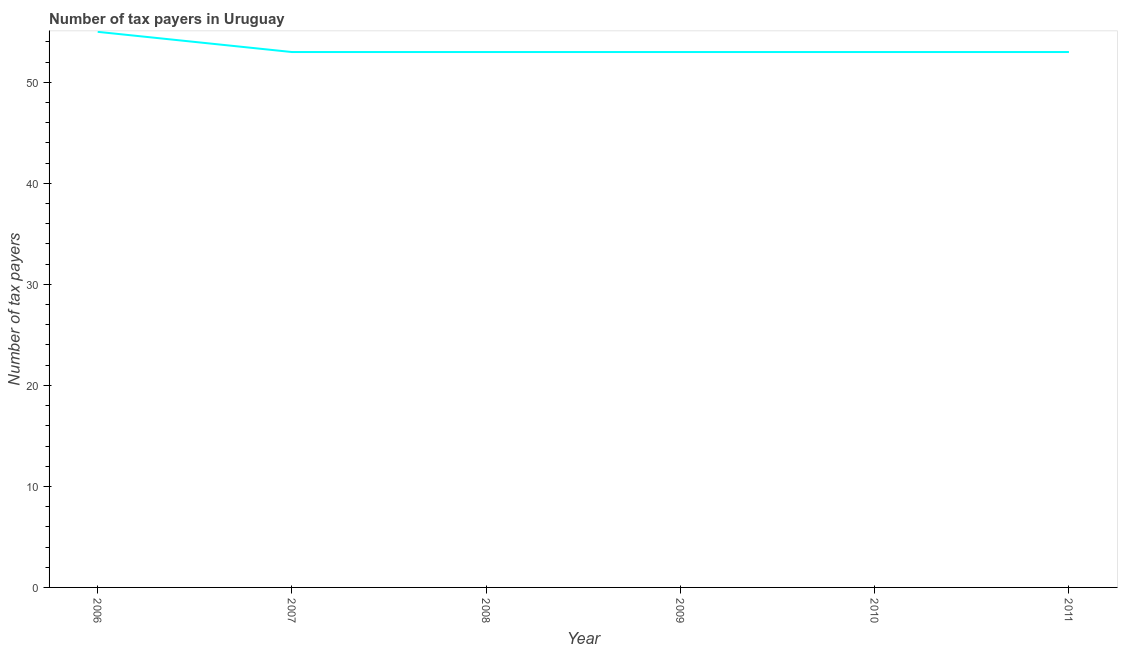What is the number of tax payers in 2009?
Ensure brevity in your answer.  53. Across all years, what is the maximum number of tax payers?
Your answer should be very brief. 55. Across all years, what is the minimum number of tax payers?
Provide a short and direct response. 53. In which year was the number of tax payers maximum?
Give a very brief answer. 2006. In which year was the number of tax payers minimum?
Your answer should be compact. 2007. What is the sum of the number of tax payers?
Your response must be concise. 320. What is the difference between the number of tax payers in 2007 and 2008?
Your response must be concise. 0. What is the average number of tax payers per year?
Offer a terse response. 53.33. What is the median number of tax payers?
Your answer should be very brief. 53. In how many years, is the number of tax payers greater than 10 ?
Provide a short and direct response. 6. What is the ratio of the number of tax payers in 2007 to that in 2009?
Provide a succinct answer. 1. Is the sum of the number of tax payers in 2008 and 2010 greater than the maximum number of tax payers across all years?
Your response must be concise. Yes. What is the difference between the highest and the lowest number of tax payers?
Give a very brief answer. 2. How many years are there in the graph?
Offer a terse response. 6. What is the difference between two consecutive major ticks on the Y-axis?
Keep it short and to the point. 10. Does the graph contain any zero values?
Your answer should be very brief. No. Does the graph contain grids?
Offer a terse response. No. What is the title of the graph?
Ensure brevity in your answer.  Number of tax payers in Uruguay. What is the label or title of the X-axis?
Your answer should be very brief. Year. What is the label or title of the Y-axis?
Keep it short and to the point. Number of tax payers. What is the Number of tax payers in 2007?
Your answer should be compact. 53. What is the Number of tax payers of 2011?
Provide a short and direct response. 53. What is the difference between the Number of tax payers in 2006 and 2007?
Provide a succinct answer. 2. What is the difference between the Number of tax payers in 2006 and 2011?
Give a very brief answer. 2. What is the difference between the Number of tax payers in 2007 and 2011?
Provide a short and direct response. 0. What is the difference between the Number of tax payers in 2008 and 2010?
Keep it short and to the point. 0. What is the difference between the Number of tax payers in 2008 and 2011?
Offer a very short reply. 0. What is the difference between the Number of tax payers in 2009 and 2010?
Provide a succinct answer. 0. What is the difference between the Number of tax payers in 2009 and 2011?
Provide a succinct answer. 0. What is the ratio of the Number of tax payers in 2006 to that in 2007?
Your response must be concise. 1.04. What is the ratio of the Number of tax payers in 2006 to that in 2008?
Your answer should be compact. 1.04. What is the ratio of the Number of tax payers in 2006 to that in 2009?
Provide a short and direct response. 1.04. What is the ratio of the Number of tax payers in 2006 to that in 2010?
Offer a terse response. 1.04. What is the ratio of the Number of tax payers in 2006 to that in 2011?
Offer a terse response. 1.04. What is the ratio of the Number of tax payers in 2007 to that in 2011?
Ensure brevity in your answer.  1. What is the ratio of the Number of tax payers in 2008 to that in 2010?
Make the answer very short. 1. What is the ratio of the Number of tax payers in 2008 to that in 2011?
Provide a succinct answer. 1. What is the ratio of the Number of tax payers in 2009 to that in 2011?
Make the answer very short. 1. What is the ratio of the Number of tax payers in 2010 to that in 2011?
Offer a very short reply. 1. 